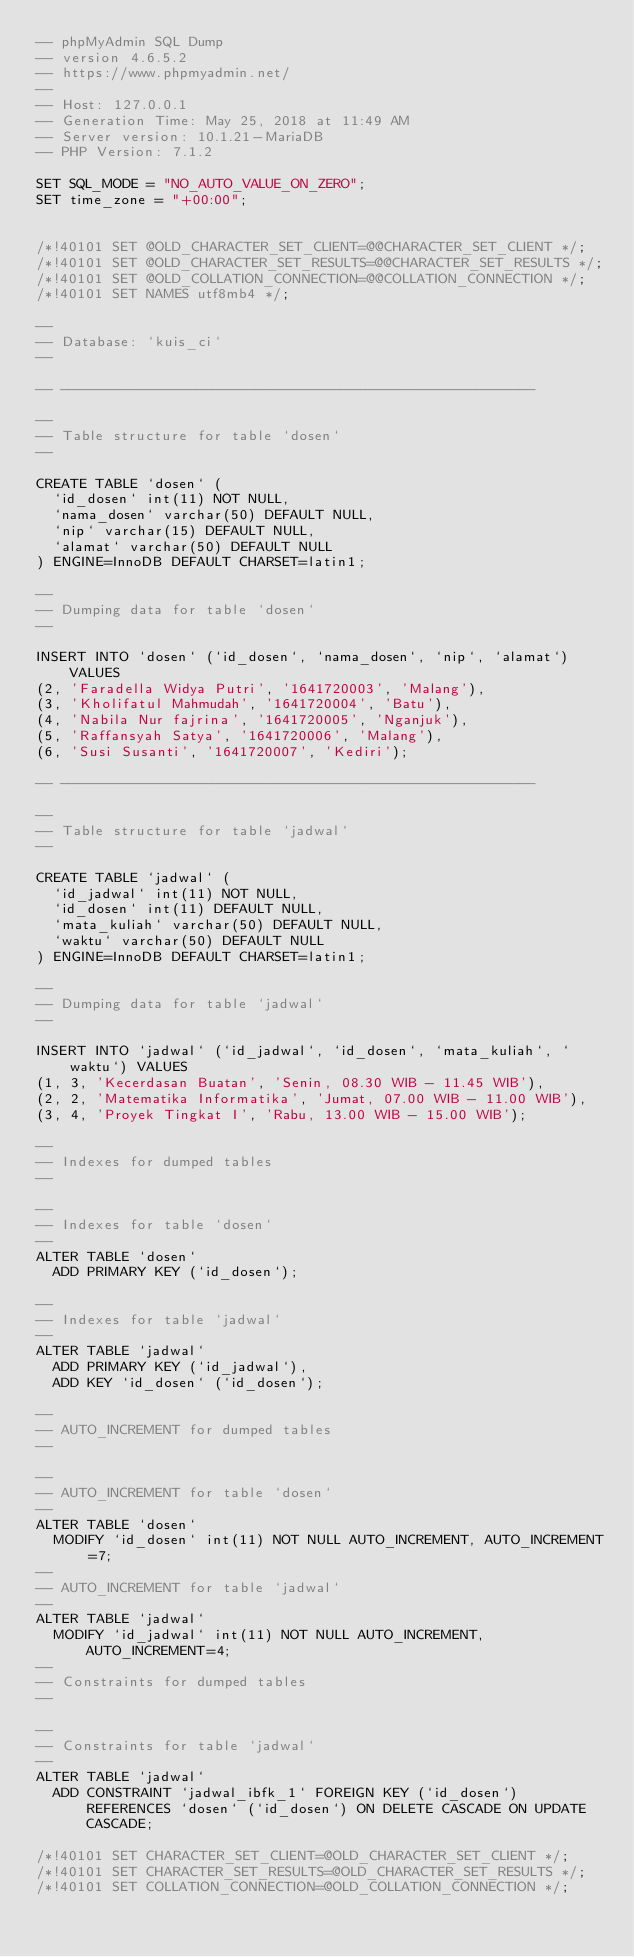Convert code to text. <code><loc_0><loc_0><loc_500><loc_500><_SQL_>-- phpMyAdmin SQL Dump
-- version 4.6.5.2
-- https://www.phpmyadmin.net/
--
-- Host: 127.0.0.1
-- Generation Time: May 25, 2018 at 11:49 AM
-- Server version: 10.1.21-MariaDB
-- PHP Version: 7.1.2

SET SQL_MODE = "NO_AUTO_VALUE_ON_ZERO";
SET time_zone = "+00:00";


/*!40101 SET @OLD_CHARACTER_SET_CLIENT=@@CHARACTER_SET_CLIENT */;
/*!40101 SET @OLD_CHARACTER_SET_RESULTS=@@CHARACTER_SET_RESULTS */;
/*!40101 SET @OLD_COLLATION_CONNECTION=@@COLLATION_CONNECTION */;
/*!40101 SET NAMES utf8mb4 */;

--
-- Database: `kuis_ci`
--

-- --------------------------------------------------------

--
-- Table structure for table `dosen`
--

CREATE TABLE `dosen` (
  `id_dosen` int(11) NOT NULL,
  `nama_dosen` varchar(50) DEFAULT NULL,
  `nip` varchar(15) DEFAULT NULL,
  `alamat` varchar(50) DEFAULT NULL
) ENGINE=InnoDB DEFAULT CHARSET=latin1;

--
-- Dumping data for table `dosen`
--

INSERT INTO `dosen` (`id_dosen`, `nama_dosen`, `nip`, `alamat`) VALUES
(2, 'Faradella Widya Putri', '1641720003', 'Malang'),
(3, 'Kholifatul Mahmudah', '1641720004', 'Batu'),
(4, 'Nabila Nur fajrina', '1641720005', 'Nganjuk'),
(5, 'Raffansyah Satya', '1641720006', 'Malang'),
(6, 'Susi Susanti', '1641720007', 'Kediri');

-- --------------------------------------------------------

--
-- Table structure for table `jadwal`
--

CREATE TABLE `jadwal` (
  `id_jadwal` int(11) NOT NULL,
  `id_dosen` int(11) DEFAULT NULL,
  `mata_kuliah` varchar(50) DEFAULT NULL,
  `waktu` varchar(50) DEFAULT NULL
) ENGINE=InnoDB DEFAULT CHARSET=latin1;

--
-- Dumping data for table `jadwal`
--

INSERT INTO `jadwal` (`id_jadwal`, `id_dosen`, `mata_kuliah`, `waktu`) VALUES
(1, 3, 'Kecerdasan Buatan', 'Senin, 08.30 WIB - 11.45 WIB'),
(2, 2, 'Matematika Informatika', 'Jumat, 07.00 WIB - 11.00 WIB'),
(3, 4, 'Proyek Tingkat I', 'Rabu, 13.00 WIB - 15.00 WIB');

--
-- Indexes for dumped tables
--

--
-- Indexes for table `dosen`
--
ALTER TABLE `dosen`
  ADD PRIMARY KEY (`id_dosen`);

--
-- Indexes for table `jadwal`
--
ALTER TABLE `jadwal`
  ADD PRIMARY KEY (`id_jadwal`),
  ADD KEY `id_dosen` (`id_dosen`);

--
-- AUTO_INCREMENT for dumped tables
--

--
-- AUTO_INCREMENT for table `dosen`
--
ALTER TABLE `dosen`
  MODIFY `id_dosen` int(11) NOT NULL AUTO_INCREMENT, AUTO_INCREMENT=7;
--
-- AUTO_INCREMENT for table `jadwal`
--
ALTER TABLE `jadwal`
  MODIFY `id_jadwal` int(11) NOT NULL AUTO_INCREMENT, AUTO_INCREMENT=4;
--
-- Constraints for dumped tables
--

--
-- Constraints for table `jadwal`
--
ALTER TABLE `jadwal`
  ADD CONSTRAINT `jadwal_ibfk_1` FOREIGN KEY (`id_dosen`) REFERENCES `dosen` (`id_dosen`) ON DELETE CASCADE ON UPDATE CASCADE;

/*!40101 SET CHARACTER_SET_CLIENT=@OLD_CHARACTER_SET_CLIENT */;
/*!40101 SET CHARACTER_SET_RESULTS=@OLD_CHARACTER_SET_RESULTS */;
/*!40101 SET COLLATION_CONNECTION=@OLD_COLLATION_CONNECTION */;
</code> 